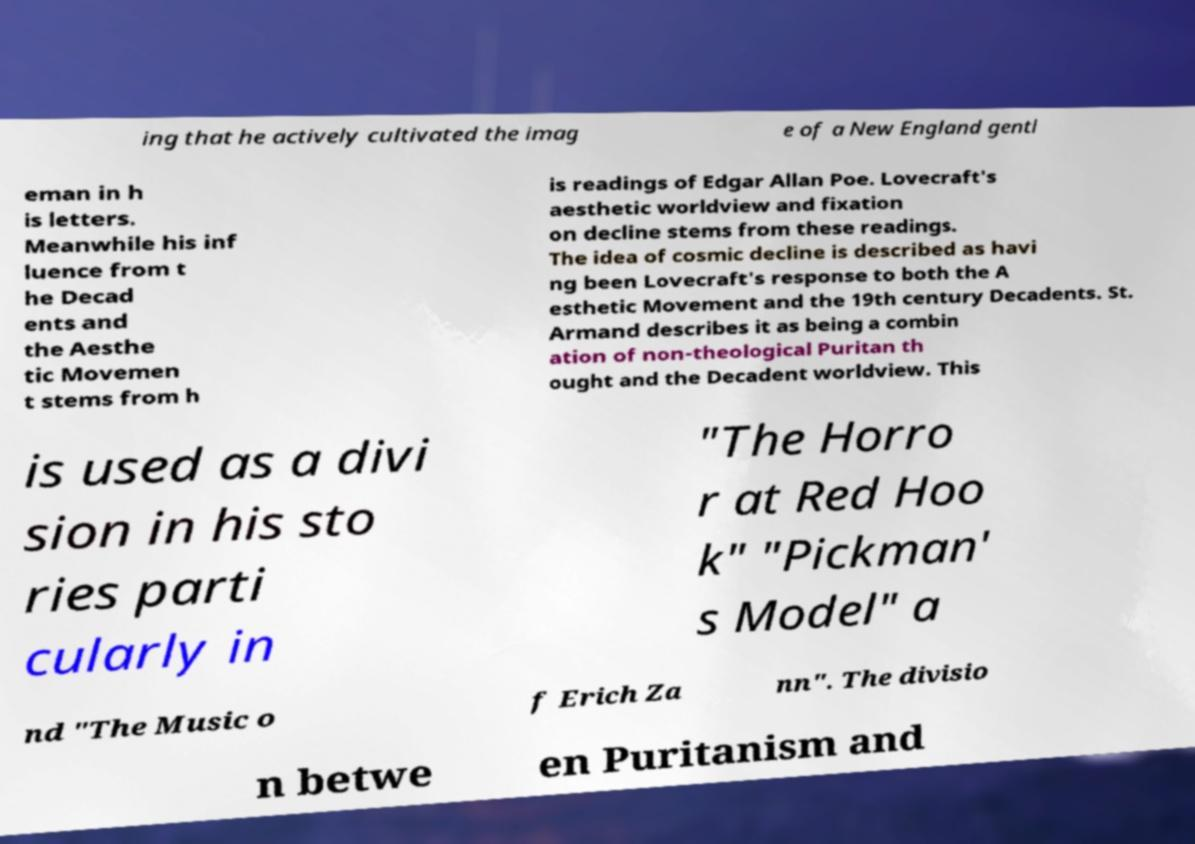For documentation purposes, I need the text within this image transcribed. Could you provide that? ing that he actively cultivated the imag e of a New England gentl eman in h is letters. Meanwhile his inf luence from t he Decad ents and the Aesthe tic Movemen t stems from h is readings of Edgar Allan Poe. Lovecraft's aesthetic worldview and fixation on decline stems from these readings. The idea of cosmic decline is described as havi ng been Lovecraft's response to both the A esthetic Movement and the 19th century Decadents. St. Armand describes it as being a combin ation of non-theological Puritan th ought and the Decadent worldview. This is used as a divi sion in his sto ries parti cularly in "The Horro r at Red Hoo k" "Pickman' s Model" a nd "The Music o f Erich Za nn". The divisio n betwe en Puritanism and 